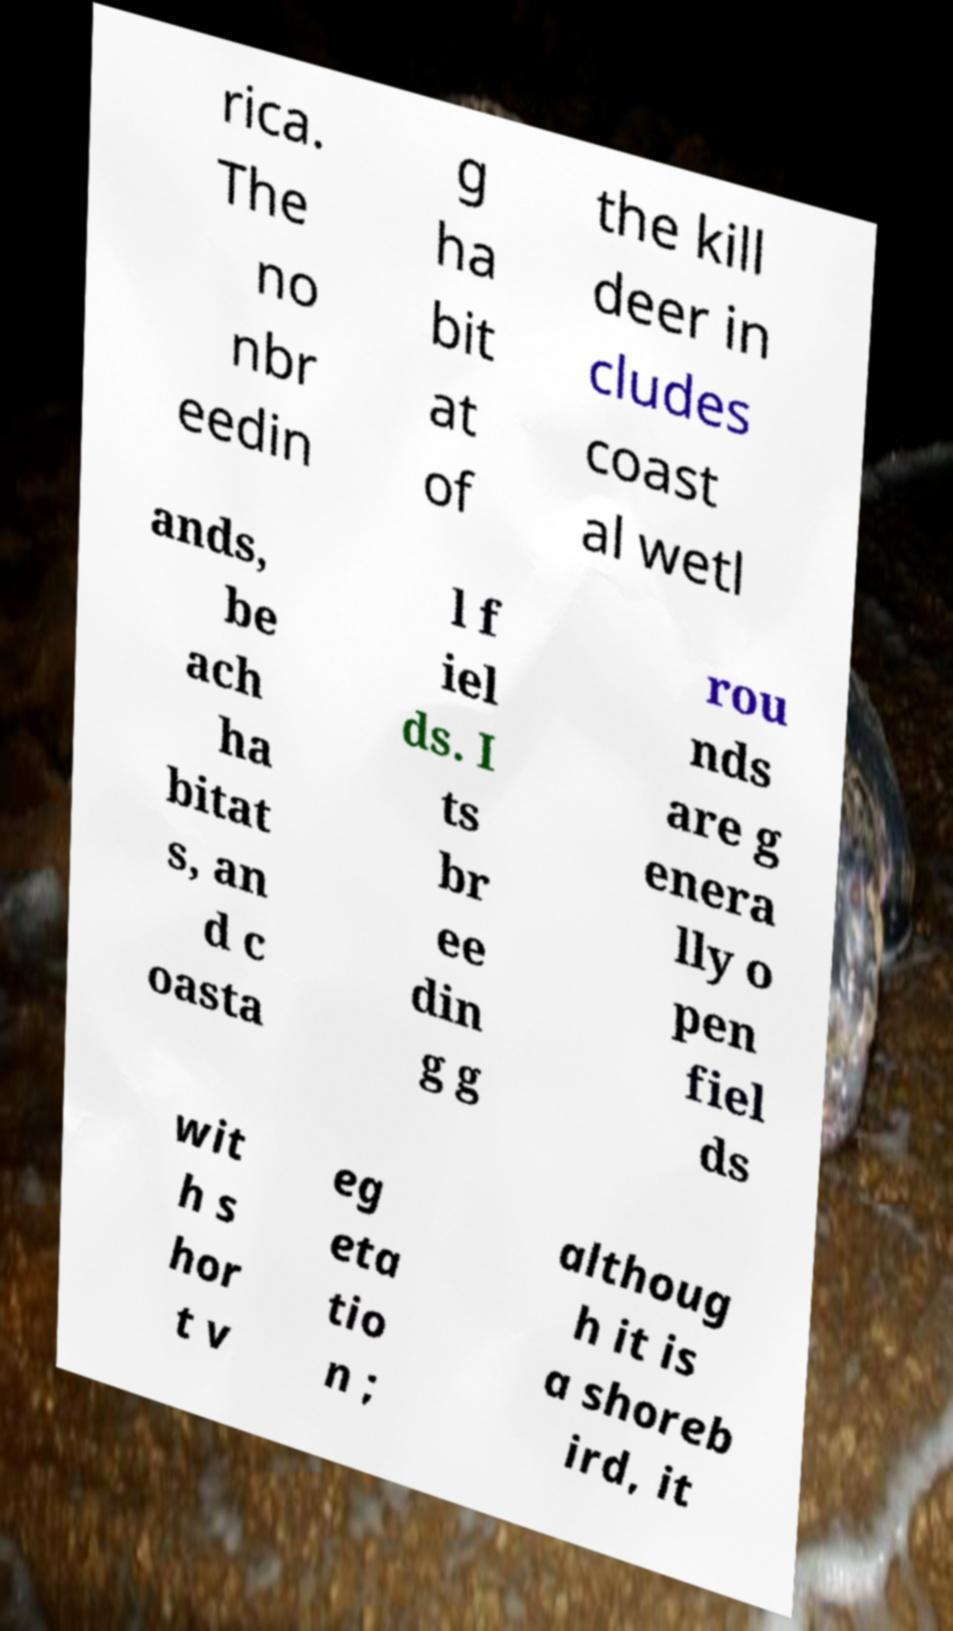Can you read and provide the text displayed in the image?This photo seems to have some interesting text. Can you extract and type it out for me? rica. The no nbr eedin g ha bit at of the kill deer in cludes coast al wetl ands, be ach ha bitat s, an d c oasta l f iel ds. I ts br ee din g g rou nds are g enera lly o pen fiel ds wit h s hor t v eg eta tio n ; althoug h it is a shoreb ird, it 